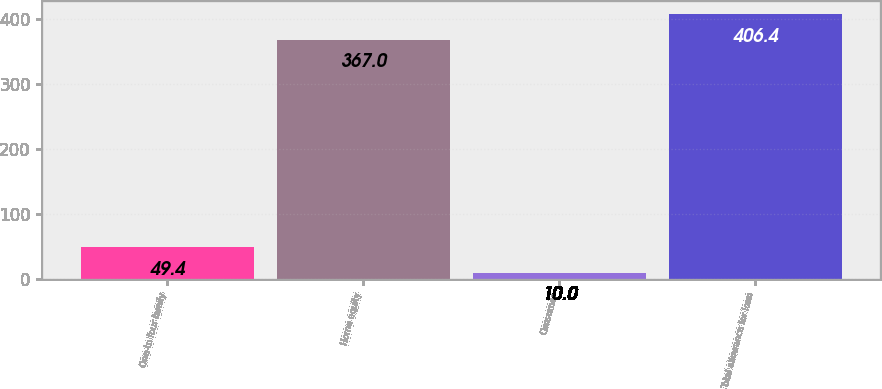Convert chart. <chart><loc_0><loc_0><loc_500><loc_500><bar_chart><fcel>One-to four family<fcel>Home equity<fcel>Consumer<fcel>Total allowance for loan<nl><fcel>49.4<fcel>367<fcel>10<fcel>406.4<nl></chart> 